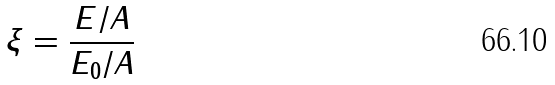Convert formula to latex. <formula><loc_0><loc_0><loc_500><loc_500>\xi = \frac { E / A } { { E _ { 0 } / A } } \</formula> 